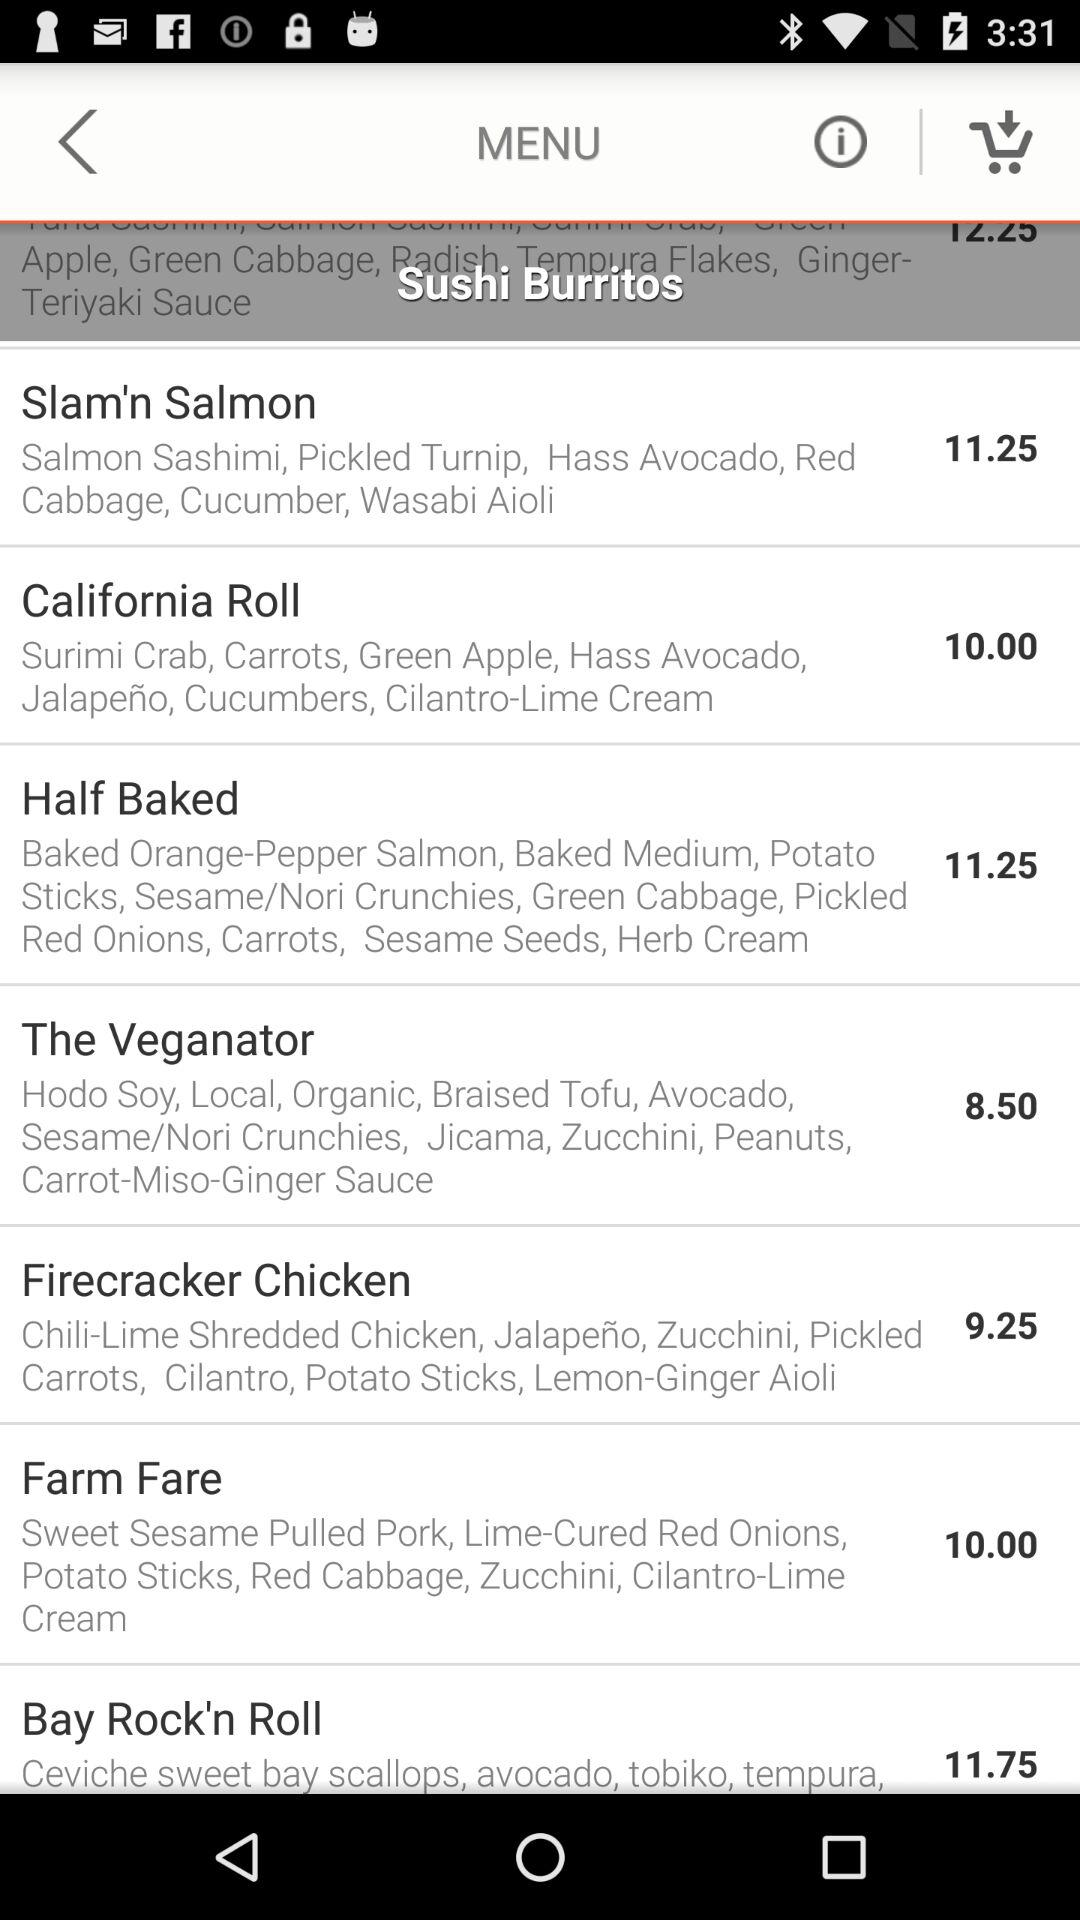What does half-baked include? The half-baked include "Baked Orange-Pepper Salmon, Baked Medium, Potato Sticks, Sesame/Nori Crunchies, Green Cabbage, Pickled Red Onions, Carrots, Sesame Seeds, Herb Cream". 